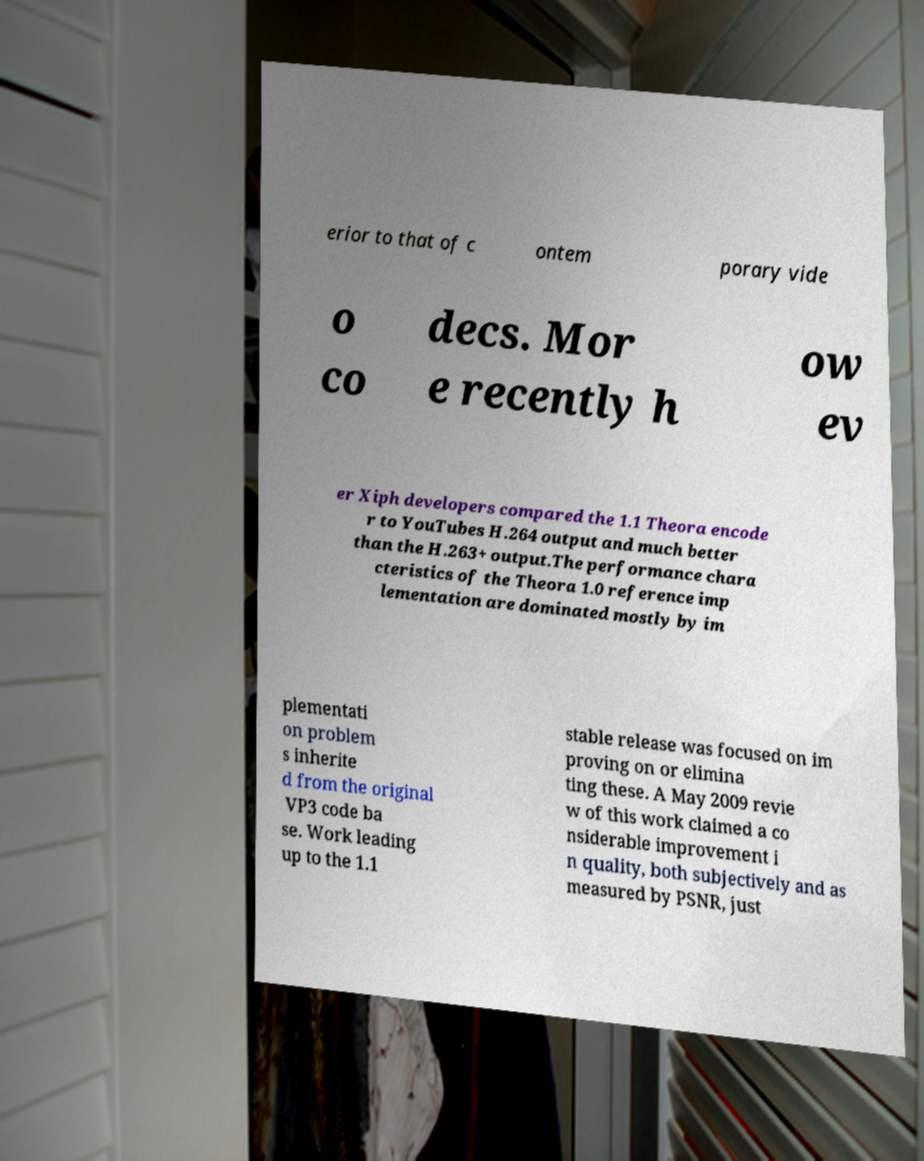Please read and relay the text visible in this image. What does it say? erior to that of c ontem porary vide o co decs. Mor e recently h ow ev er Xiph developers compared the 1.1 Theora encode r to YouTubes H.264 output and much better than the H.263+ output.The performance chara cteristics of the Theora 1.0 reference imp lementation are dominated mostly by im plementati on problem s inherite d from the original VP3 code ba se. Work leading up to the 1.1 stable release was focused on im proving on or elimina ting these. A May 2009 revie w of this work claimed a co nsiderable improvement i n quality, both subjectively and as measured by PSNR, just 